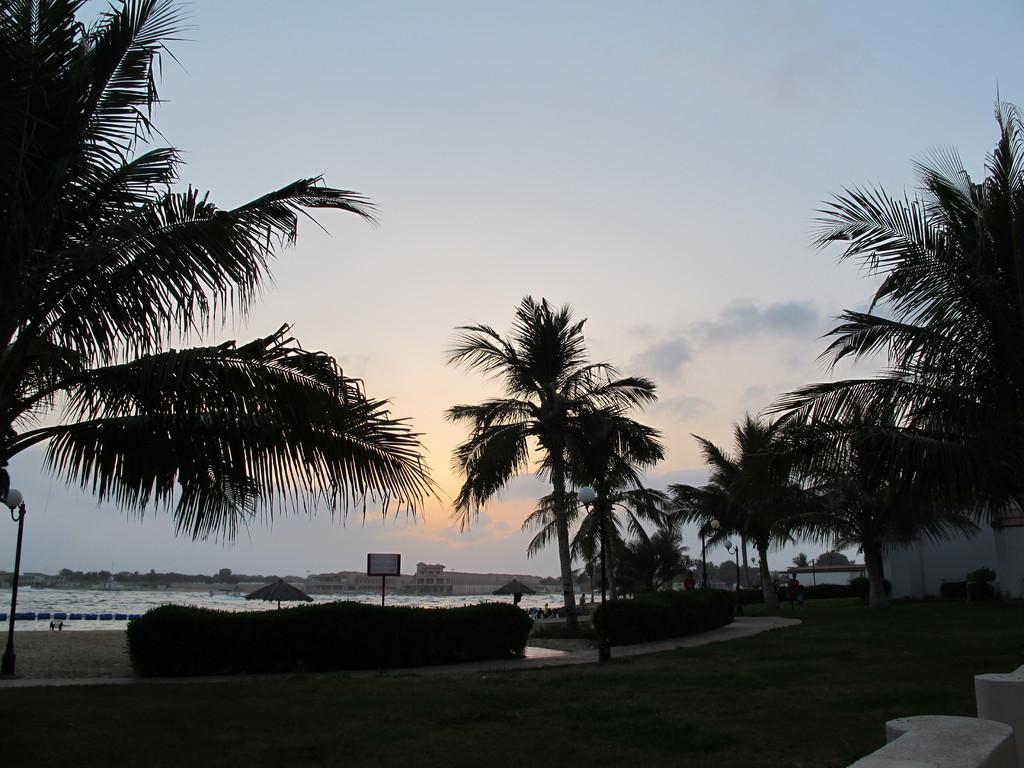How would you summarize this image in a sentence or two? Here in this picture we can see the ground is covered with grass and we can also see bushes, plants and trees and in the far we can see an umbrella present and we can also see water covered over the place and we can also see a board present in the middle and on the left side we can see a lamp post present and we can see clouds in the sky. 